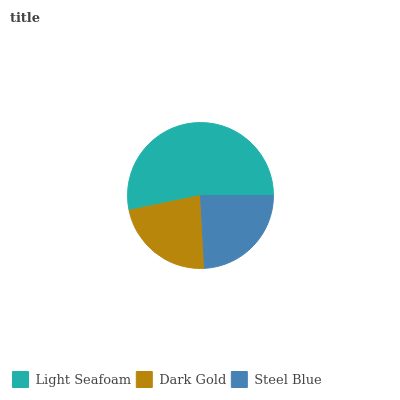Is Dark Gold the minimum?
Answer yes or no. Yes. Is Light Seafoam the maximum?
Answer yes or no. Yes. Is Steel Blue the minimum?
Answer yes or no. No. Is Steel Blue the maximum?
Answer yes or no. No. Is Steel Blue greater than Dark Gold?
Answer yes or no. Yes. Is Dark Gold less than Steel Blue?
Answer yes or no. Yes. Is Dark Gold greater than Steel Blue?
Answer yes or no. No. Is Steel Blue less than Dark Gold?
Answer yes or no. No. Is Steel Blue the high median?
Answer yes or no. Yes. Is Steel Blue the low median?
Answer yes or no. Yes. Is Light Seafoam the high median?
Answer yes or no. No. Is Light Seafoam the low median?
Answer yes or no. No. 